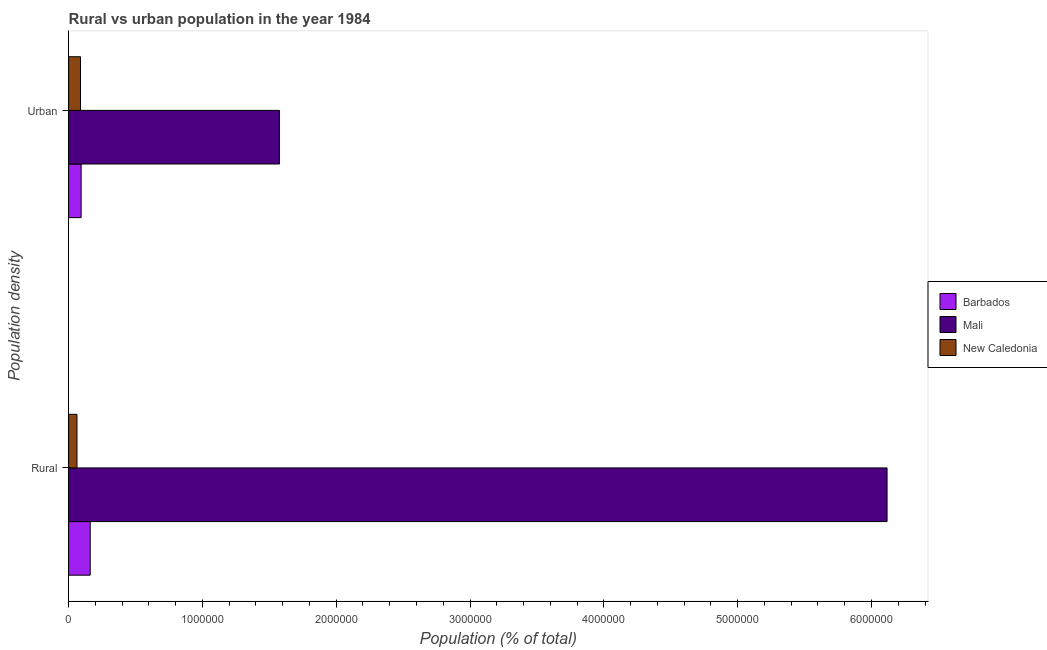Are the number of bars on each tick of the Y-axis equal?
Offer a terse response. Yes. How many bars are there on the 1st tick from the top?
Give a very brief answer. 3. What is the label of the 1st group of bars from the top?
Offer a very short reply. Urban. What is the rural population density in Barbados?
Your answer should be compact. 1.62e+05. Across all countries, what is the maximum urban population density?
Keep it short and to the point. 1.58e+06. Across all countries, what is the minimum rural population density?
Give a very brief answer. 6.27e+04. In which country was the rural population density maximum?
Offer a very short reply. Mali. In which country was the rural population density minimum?
Your response must be concise. New Caledonia. What is the total rural population density in the graph?
Your answer should be compact. 6.34e+06. What is the difference between the urban population density in New Caledonia and that in Barbados?
Your answer should be very brief. -4625. What is the difference between the urban population density in Barbados and the rural population density in New Caledonia?
Offer a terse response. 3.10e+04. What is the average urban population density per country?
Make the answer very short. 5.86e+05. What is the difference between the urban population density and rural population density in New Caledonia?
Make the answer very short. 2.63e+04. In how many countries, is the urban population density greater than 2200000 %?
Your response must be concise. 0. What is the ratio of the rural population density in New Caledonia to that in Barbados?
Offer a terse response. 0.39. Is the rural population density in New Caledonia less than that in Barbados?
Offer a very short reply. Yes. What does the 3rd bar from the top in Urban represents?
Your answer should be very brief. Barbados. What does the 2nd bar from the bottom in Urban represents?
Ensure brevity in your answer.  Mali. How many bars are there?
Ensure brevity in your answer.  6. Are all the bars in the graph horizontal?
Give a very brief answer. Yes. Does the graph contain grids?
Your answer should be very brief. No. Where does the legend appear in the graph?
Provide a succinct answer. Center right. How many legend labels are there?
Your answer should be very brief. 3. What is the title of the graph?
Offer a terse response. Rural vs urban population in the year 1984. What is the label or title of the X-axis?
Provide a succinct answer. Population (% of total). What is the label or title of the Y-axis?
Offer a very short reply. Population density. What is the Population (% of total) of Barbados in Rural?
Give a very brief answer. 1.62e+05. What is the Population (% of total) of Mali in Rural?
Keep it short and to the point. 6.12e+06. What is the Population (% of total) of New Caledonia in Rural?
Ensure brevity in your answer.  6.27e+04. What is the Population (% of total) of Barbados in Urban?
Ensure brevity in your answer.  9.36e+04. What is the Population (% of total) of Mali in Urban?
Keep it short and to the point. 1.58e+06. What is the Population (% of total) of New Caledonia in Urban?
Offer a terse response. 8.90e+04. Across all Population density, what is the maximum Population (% of total) in Barbados?
Keep it short and to the point. 1.62e+05. Across all Population density, what is the maximum Population (% of total) in Mali?
Keep it short and to the point. 6.12e+06. Across all Population density, what is the maximum Population (% of total) in New Caledonia?
Ensure brevity in your answer.  8.90e+04. Across all Population density, what is the minimum Population (% of total) of Barbados?
Provide a succinct answer. 9.36e+04. Across all Population density, what is the minimum Population (% of total) of Mali?
Provide a succinct answer. 1.58e+06. Across all Population density, what is the minimum Population (% of total) in New Caledonia?
Your answer should be very brief. 6.27e+04. What is the total Population (% of total) in Barbados in the graph?
Your response must be concise. 2.55e+05. What is the total Population (% of total) of Mali in the graph?
Make the answer very short. 7.69e+06. What is the total Population (% of total) in New Caledonia in the graph?
Your response must be concise. 1.52e+05. What is the difference between the Population (% of total) of Barbados in Rural and that in Urban?
Provide a succinct answer. 6.80e+04. What is the difference between the Population (% of total) in Mali in Rural and that in Urban?
Your answer should be very brief. 4.54e+06. What is the difference between the Population (% of total) of New Caledonia in Rural and that in Urban?
Provide a short and direct response. -2.63e+04. What is the difference between the Population (% of total) in Barbados in Rural and the Population (% of total) in Mali in Urban?
Offer a very short reply. -1.41e+06. What is the difference between the Population (% of total) in Barbados in Rural and the Population (% of total) in New Caledonia in Urban?
Your answer should be compact. 7.26e+04. What is the difference between the Population (% of total) of Mali in Rural and the Population (% of total) of New Caledonia in Urban?
Make the answer very short. 6.03e+06. What is the average Population (% of total) in Barbados per Population density?
Your response must be concise. 1.28e+05. What is the average Population (% of total) of Mali per Population density?
Provide a short and direct response. 3.85e+06. What is the average Population (% of total) of New Caledonia per Population density?
Offer a terse response. 7.58e+04. What is the difference between the Population (% of total) of Barbados and Population (% of total) of Mali in Rural?
Your answer should be very brief. -5.95e+06. What is the difference between the Population (% of total) in Barbados and Population (% of total) in New Caledonia in Rural?
Offer a terse response. 9.89e+04. What is the difference between the Population (% of total) of Mali and Population (% of total) of New Caledonia in Rural?
Provide a short and direct response. 6.05e+06. What is the difference between the Population (% of total) in Barbados and Population (% of total) in Mali in Urban?
Provide a short and direct response. -1.48e+06. What is the difference between the Population (% of total) in Barbados and Population (% of total) in New Caledonia in Urban?
Make the answer very short. 4625. What is the difference between the Population (% of total) of Mali and Population (% of total) of New Caledonia in Urban?
Your answer should be very brief. 1.49e+06. What is the ratio of the Population (% of total) in Barbados in Rural to that in Urban?
Keep it short and to the point. 1.73. What is the ratio of the Population (% of total) of Mali in Rural to that in Urban?
Offer a very short reply. 3.88. What is the ratio of the Population (% of total) in New Caledonia in Rural to that in Urban?
Provide a short and direct response. 0.7. What is the difference between the highest and the second highest Population (% of total) of Barbados?
Provide a succinct answer. 6.80e+04. What is the difference between the highest and the second highest Population (% of total) in Mali?
Your response must be concise. 4.54e+06. What is the difference between the highest and the second highest Population (% of total) of New Caledonia?
Keep it short and to the point. 2.63e+04. What is the difference between the highest and the lowest Population (% of total) in Barbados?
Keep it short and to the point. 6.80e+04. What is the difference between the highest and the lowest Population (% of total) of Mali?
Offer a terse response. 4.54e+06. What is the difference between the highest and the lowest Population (% of total) in New Caledonia?
Give a very brief answer. 2.63e+04. 